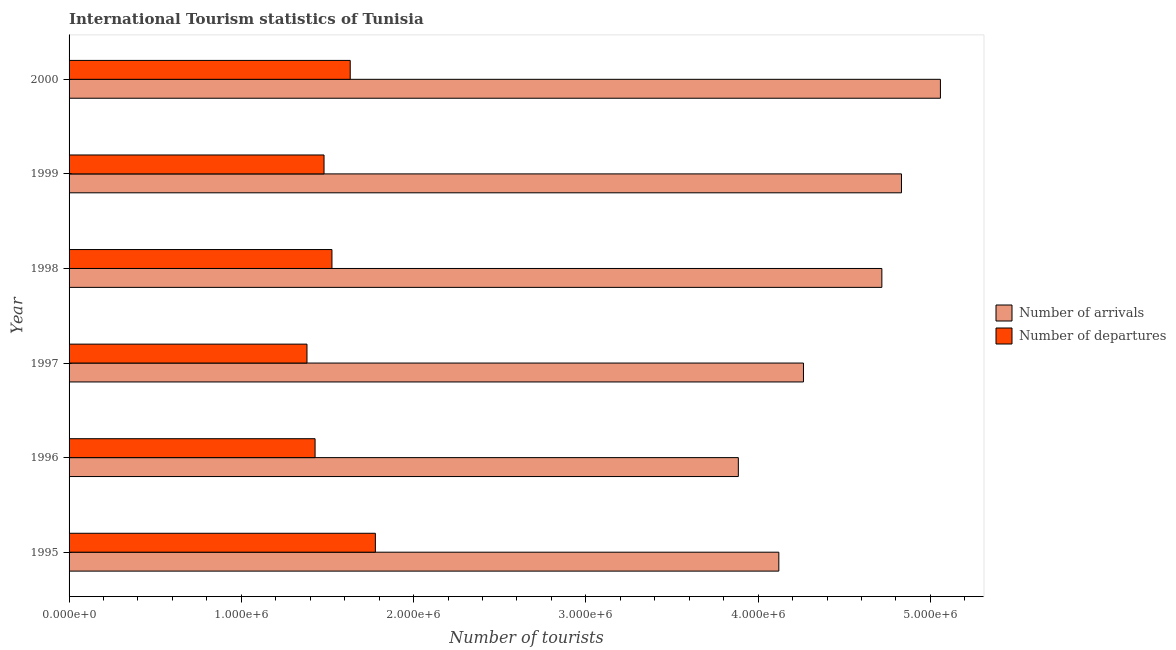Are the number of bars on each tick of the Y-axis equal?
Your answer should be compact. Yes. How many bars are there on the 1st tick from the bottom?
Give a very brief answer. 2. In how many cases, is the number of bars for a given year not equal to the number of legend labels?
Offer a very short reply. 0. What is the number of tourist departures in 2000?
Provide a succinct answer. 1.63e+06. Across all years, what is the maximum number of tourist arrivals?
Your answer should be very brief. 5.06e+06. Across all years, what is the minimum number of tourist departures?
Give a very brief answer. 1.38e+06. In which year was the number of tourist departures maximum?
Your answer should be very brief. 1995. What is the total number of tourist departures in the graph?
Keep it short and to the point. 9.22e+06. What is the difference between the number of tourist arrivals in 1997 and that in 1999?
Make the answer very short. -5.69e+05. What is the difference between the number of tourist departures in 1998 and the number of tourist arrivals in 1996?
Provide a short and direct response. -2.36e+06. What is the average number of tourist arrivals per year?
Your response must be concise. 4.48e+06. In the year 1997, what is the difference between the number of tourist arrivals and number of tourist departures?
Keep it short and to the point. 2.88e+06. In how many years, is the number of tourist arrivals greater than 4600000 ?
Make the answer very short. 3. What is the ratio of the number of tourist departures in 1996 to that in 1998?
Keep it short and to the point. 0.94. Is the difference between the number of tourist arrivals in 1998 and 2000 greater than the difference between the number of tourist departures in 1998 and 2000?
Your response must be concise. No. What is the difference between the highest and the second highest number of tourist arrivals?
Offer a terse response. 2.26e+05. What is the difference between the highest and the lowest number of tourist arrivals?
Offer a terse response. 1.17e+06. In how many years, is the number of tourist arrivals greater than the average number of tourist arrivals taken over all years?
Make the answer very short. 3. Is the sum of the number of tourist arrivals in 1995 and 1998 greater than the maximum number of tourist departures across all years?
Your response must be concise. Yes. What does the 1st bar from the top in 1996 represents?
Give a very brief answer. Number of departures. What does the 2nd bar from the bottom in 1997 represents?
Provide a succinct answer. Number of departures. Are all the bars in the graph horizontal?
Ensure brevity in your answer.  Yes. How many legend labels are there?
Offer a terse response. 2. How are the legend labels stacked?
Offer a terse response. Vertical. What is the title of the graph?
Provide a succinct answer. International Tourism statistics of Tunisia. What is the label or title of the X-axis?
Give a very brief answer. Number of tourists. What is the label or title of the Y-axis?
Offer a terse response. Year. What is the Number of tourists of Number of arrivals in 1995?
Your answer should be very brief. 4.12e+06. What is the Number of tourists of Number of departures in 1995?
Your answer should be compact. 1.78e+06. What is the Number of tourists in Number of arrivals in 1996?
Offer a terse response. 3.88e+06. What is the Number of tourists in Number of departures in 1996?
Provide a succinct answer. 1.43e+06. What is the Number of tourists in Number of arrivals in 1997?
Provide a short and direct response. 4.26e+06. What is the Number of tourists in Number of departures in 1997?
Make the answer very short. 1.38e+06. What is the Number of tourists of Number of arrivals in 1998?
Provide a short and direct response. 4.72e+06. What is the Number of tourists of Number of departures in 1998?
Keep it short and to the point. 1.53e+06. What is the Number of tourists in Number of arrivals in 1999?
Provide a succinct answer. 4.83e+06. What is the Number of tourists of Number of departures in 1999?
Offer a terse response. 1.48e+06. What is the Number of tourists of Number of arrivals in 2000?
Offer a very short reply. 5.06e+06. What is the Number of tourists of Number of departures in 2000?
Ensure brevity in your answer.  1.63e+06. Across all years, what is the maximum Number of tourists of Number of arrivals?
Offer a terse response. 5.06e+06. Across all years, what is the maximum Number of tourists in Number of departures?
Ensure brevity in your answer.  1.78e+06. Across all years, what is the minimum Number of tourists in Number of arrivals?
Make the answer very short. 3.88e+06. Across all years, what is the minimum Number of tourists of Number of departures?
Give a very brief answer. 1.38e+06. What is the total Number of tourists in Number of arrivals in the graph?
Provide a short and direct response. 2.69e+07. What is the total Number of tourists of Number of departures in the graph?
Ensure brevity in your answer.  9.22e+06. What is the difference between the Number of tourists of Number of arrivals in 1995 and that in 1996?
Offer a very short reply. 2.35e+05. What is the difference between the Number of tourists of Number of arrivals in 1995 and that in 1997?
Your answer should be very brief. -1.43e+05. What is the difference between the Number of tourists in Number of departures in 1995 and that in 1997?
Offer a very short reply. 3.97e+05. What is the difference between the Number of tourists in Number of arrivals in 1995 and that in 1998?
Provide a short and direct response. -5.98e+05. What is the difference between the Number of tourists in Number of departures in 1995 and that in 1998?
Ensure brevity in your answer.  2.52e+05. What is the difference between the Number of tourists in Number of arrivals in 1995 and that in 1999?
Your answer should be compact. -7.12e+05. What is the difference between the Number of tourists in Number of departures in 1995 and that in 1999?
Your response must be concise. 2.98e+05. What is the difference between the Number of tourists in Number of arrivals in 1995 and that in 2000?
Make the answer very short. -9.38e+05. What is the difference between the Number of tourists of Number of departures in 1995 and that in 2000?
Provide a succinct answer. 1.46e+05. What is the difference between the Number of tourists of Number of arrivals in 1996 and that in 1997?
Provide a short and direct response. -3.78e+05. What is the difference between the Number of tourists of Number of departures in 1996 and that in 1997?
Your response must be concise. 4.70e+04. What is the difference between the Number of tourists in Number of arrivals in 1996 and that in 1998?
Ensure brevity in your answer.  -8.33e+05. What is the difference between the Number of tourists in Number of departures in 1996 and that in 1998?
Your answer should be compact. -9.80e+04. What is the difference between the Number of tourists in Number of arrivals in 1996 and that in 1999?
Give a very brief answer. -9.47e+05. What is the difference between the Number of tourists in Number of departures in 1996 and that in 1999?
Keep it short and to the point. -5.20e+04. What is the difference between the Number of tourists in Number of arrivals in 1996 and that in 2000?
Ensure brevity in your answer.  -1.17e+06. What is the difference between the Number of tourists in Number of departures in 1996 and that in 2000?
Provide a succinct answer. -2.04e+05. What is the difference between the Number of tourists in Number of arrivals in 1997 and that in 1998?
Make the answer very short. -4.55e+05. What is the difference between the Number of tourists of Number of departures in 1997 and that in 1998?
Offer a very short reply. -1.45e+05. What is the difference between the Number of tourists in Number of arrivals in 1997 and that in 1999?
Provide a succinct answer. -5.69e+05. What is the difference between the Number of tourists of Number of departures in 1997 and that in 1999?
Ensure brevity in your answer.  -9.90e+04. What is the difference between the Number of tourists in Number of arrivals in 1997 and that in 2000?
Your answer should be compact. -7.95e+05. What is the difference between the Number of tourists in Number of departures in 1997 and that in 2000?
Offer a very short reply. -2.51e+05. What is the difference between the Number of tourists of Number of arrivals in 1998 and that in 1999?
Your answer should be very brief. -1.14e+05. What is the difference between the Number of tourists of Number of departures in 1998 and that in 1999?
Offer a terse response. 4.60e+04. What is the difference between the Number of tourists in Number of arrivals in 1998 and that in 2000?
Provide a short and direct response. -3.40e+05. What is the difference between the Number of tourists of Number of departures in 1998 and that in 2000?
Your response must be concise. -1.06e+05. What is the difference between the Number of tourists in Number of arrivals in 1999 and that in 2000?
Provide a succinct answer. -2.26e+05. What is the difference between the Number of tourists of Number of departures in 1999 and that in 2000?
Provide a short and direct response. -1.52e+05. What is the difference between the Number of tourists in Number of arrivals in 1995 and the Number of tourists in Number of departures in 1996?
Ensure brevity in your answer.  2.69e+06. What is the difference between the Number of tourists of Number of arrivals in 1995 and the Number of tourists of Number of departures in 1997?
Make the answer very short. 2.74e+06. What is the difference between the Number of tourists in Number of arrivals in 1995 and the Number of tourists in Number of departures in 1998?
Offer a terse response. 2.59e+06. What is the difference between the Number of tourists in Number of arrivals in 1995 and the Number of tourists in Number of departures in 1999?
Make the answer very short. 2.64e+06. What is the difference between the Number of tourists in Number of arrivals in 1995 and the Number of tourists in Number of departures in 2000?
Offer a terse response. 2.49e+06. What is the difference between the Number of tourists of Number of arrivals in 1996 and the Number of tourists of Number of departures in 1997?
Your answer should be very brief. 2.50e+06. What is the difference between the Number of tourists of Number of arrivals in 1996 and the Number of tourists of Number of departures in 1998?
Ensure brevity in your answer.  2.36e+06. What is the difference between the Number of tourists in Number of arrivals in 1996 and the Number of tourists in Number of departures in 1999?
Your answer should be compact. 2.40e+06. What is the difference between the Number of tourists of Number of arrivals in 1996 and the Number of tourists of Number of departures in 2000?
Your response must be concise. 2.25e+06. What is the difference between the Number of tourists of Number of arrivals in 1997 and the Number of tourists of Number of departures in 1998?
Ensure brevity in your answer.  2.74e+06. What is the difference between the Number of tourists in Number of arrivals in 1997 and the Number of tourists in Number of departures in 1999?
Ensure brevity in your answer.  2.78e+06. What is the difference between the Number of tourists of Number of arrivals in 1997 and the Number of tourists of Number of departures in 2000?
Ensure brevity in your answer.  2.63e+06. What is the difference between the Number of tourists in Number of arrivals in 1998 and the Number of tourists in Number of departures in 1999?
Your answer should be very brief. 3.24e+06. What is the difference between the Number of tourists of Number of arrivals in 1998 and the Number of tourists of Number of departures in 2000?
Ensure brevity in your answer.  3.09e+06. What is the difference between the Number of tourists in Number of arrivals in 1999 and the Number of tourists in Number of departures in 2000?
Provide a succinct answer. 3.20e+06. What is the average Number of tourists in Number of arrivals per year?
Give a very brief answer. 4.48e+06. What is the average Number of tourists in Number of departures per year?
Your response must be concise. 1.54e+06. In the year 1995, what is the difference between the Number of tourists in Number of arrivals and Number of tourists in Number of departures?
Make the answer very short. 2.34e+06. In the year 1996, what is the difference between the Number of tourists in Number of arrivals and Number of tourists in Number of departures?
Offer a terse response. 2.46e+06. In the year 1997, what is the difference between the Number of tourists in Number of arrivals and Number of tourists in Number of departures?
Offer a terse response. 2.88e+06. In the year 1998, what is the difference between the Number of tourists in Number of arrivals and Number of tourists in Number of departures?
Provide a succinct answer. 3.19e+06. In the year 1999, what is the difference between the Number of tourists in Number of arrivals and Number of tourists in Number of departures?
Give a very brief answer. 3.35e+06. In the year 2000, what is the difference between the Number of tourists of Number of arrivals and Number of tourists of Number of departures?
Give a very brief answer. 3.43e+06. What is the ratio of the Number of tourists in Number of arrivals in 1995 to that in 1996?
Provide a short and direct response. 1.06. What is the ratio of the Number of tourists in Number of departures in 1995 to that in 1996?
Ensure brevity in your answer.  1.25. What is the ratio of the Number of tourists in Number of arrivals in 1995 to that in 1997?
Your answer should be very brief. 0.97. What is the ratio of the Number of tourists of Number of departures in 1995 to that in 1997?
Offer a terse response. 1.29. What is the ratio of the Number of tourists in Number of arrivals in 1995 to that in 1998?
Provide a succinct answer. 0.87. What is the ratio of the Number of tourists in Number of departures in 1995 to that in 1998?
Provide a succinct answer. 1.17. What is the ratio of the Number of tourists in Number of arrivals in 1995 to that in 1999?
Keep it short and to the point. 0.85. What is the ratio of the Number of tourists in Number of departures in 1995 to that in 1999?
Your answer should be very brief. 1.2. What is the ratio of the Number of tourists in Number of arrivals in 1995 to that in 2000?
Your response must be concise. 0.81. What is the ratio of the Number of tourists in Number of departures in 1995 to that in 2000?
Offer a very short reply. 1.09. What is the ratio of the Number of tourists in Number of arrivals in 1996 to that in 1997?
Your answer should be very brief. 0.91. What is the ratio of the Number of tourists of Number of departures in 1996 to that in 1997?
Make the answer very short. 1.03. What is the ratio of the Number of tourists of Number of arrivals in 1996 to that in 1998?
Your response must be concise. 0.82. What is the ratio of the Number of tourists in Number of departures in 1996 to that in 1998?
Offer a very short reply. 0.94. What is the ratio of the Number of tourists in Number of arrivals in 1996 to that in 1999?
Provide a succinct answer. 0.8. What is the ratio of the Number of tourists in Number of departures in 1996 to that in 1999?
Ensure brevity in your answer.  0.96. What is the ratio of the Number of tourists of Number of arrivals in 1996 to that in 2000?
Your answer should be very brief. 0.77. What is the ratio of the Number of tourists in Number of departures in 1996 to that in 2000?
Provide a short and direct response. 0.88. What is the ratio of the Number of tourists in Number of arrivals in 1997 to that in 1998?
Make the answer very short. 0.9. What is the ratio of the Number of tourists in Number of departures in 1997 to that in 1998?
Your response must be concise. 0.91. What is the ratio of the Number of tourists of Number of arrivals in 1997 to that in 1999?
Give a very brief answer. 0.88. What is the ratio of the Number of tourists in Number of departures in 1997 to that in 1999?
Provide a succinct answer. 0.93. What is the ratio of the Number of tourists of Number of arrivals in 1997 to that in 2000?
Offer a very short reply. 0.84. What is the ratio of the Number of tourists of Number of departures in 1997 to that in 2000?
Keep it short and to the point. 0.85. What is the ratio of the Number of tourists in Number of arrivals in 1998 to that in 1999?
Make the answer very short. 0.98. What is the ratio of the Number of tourists of Number of departures in 1998 to that in 1999?
Provide a succinct answer. 1.03. What is the ratio of the Number of tourists of Number of arrivals in 1998 to that in 2000?
Offer a very short reply. 0.93. What is the ratio of the Number of tourists in Number of departures in 1998 to that in 2000?
Your answer should be very brief. 0.94. What is the ratio of the Number of tourists of Number of arrivals in 1999 to that in 2000?
Your answer should be very brief. 0.96. What is the ratio of the Number of tourists of Number of departures in 1999 to that in 2000?
Give a very brief answer. 0.91. What is the difference between the highest and the second highest Number of tourists in Number of arrivals?
Your answer should be very brief. 2.26e+05. What is the difference between the highest and the second highest Number of tourists in Number of departures?
Offer a terse response. 1.46e+05. What is the difference between the highest and the lowest Number of tourists in Number of arrivals?
Your answer should be very brief. 1.17e+06. What is the difference between the highest and the lowest Number of tourists in Number of departures?
Keep it short and to the point. 3.97e+05. 